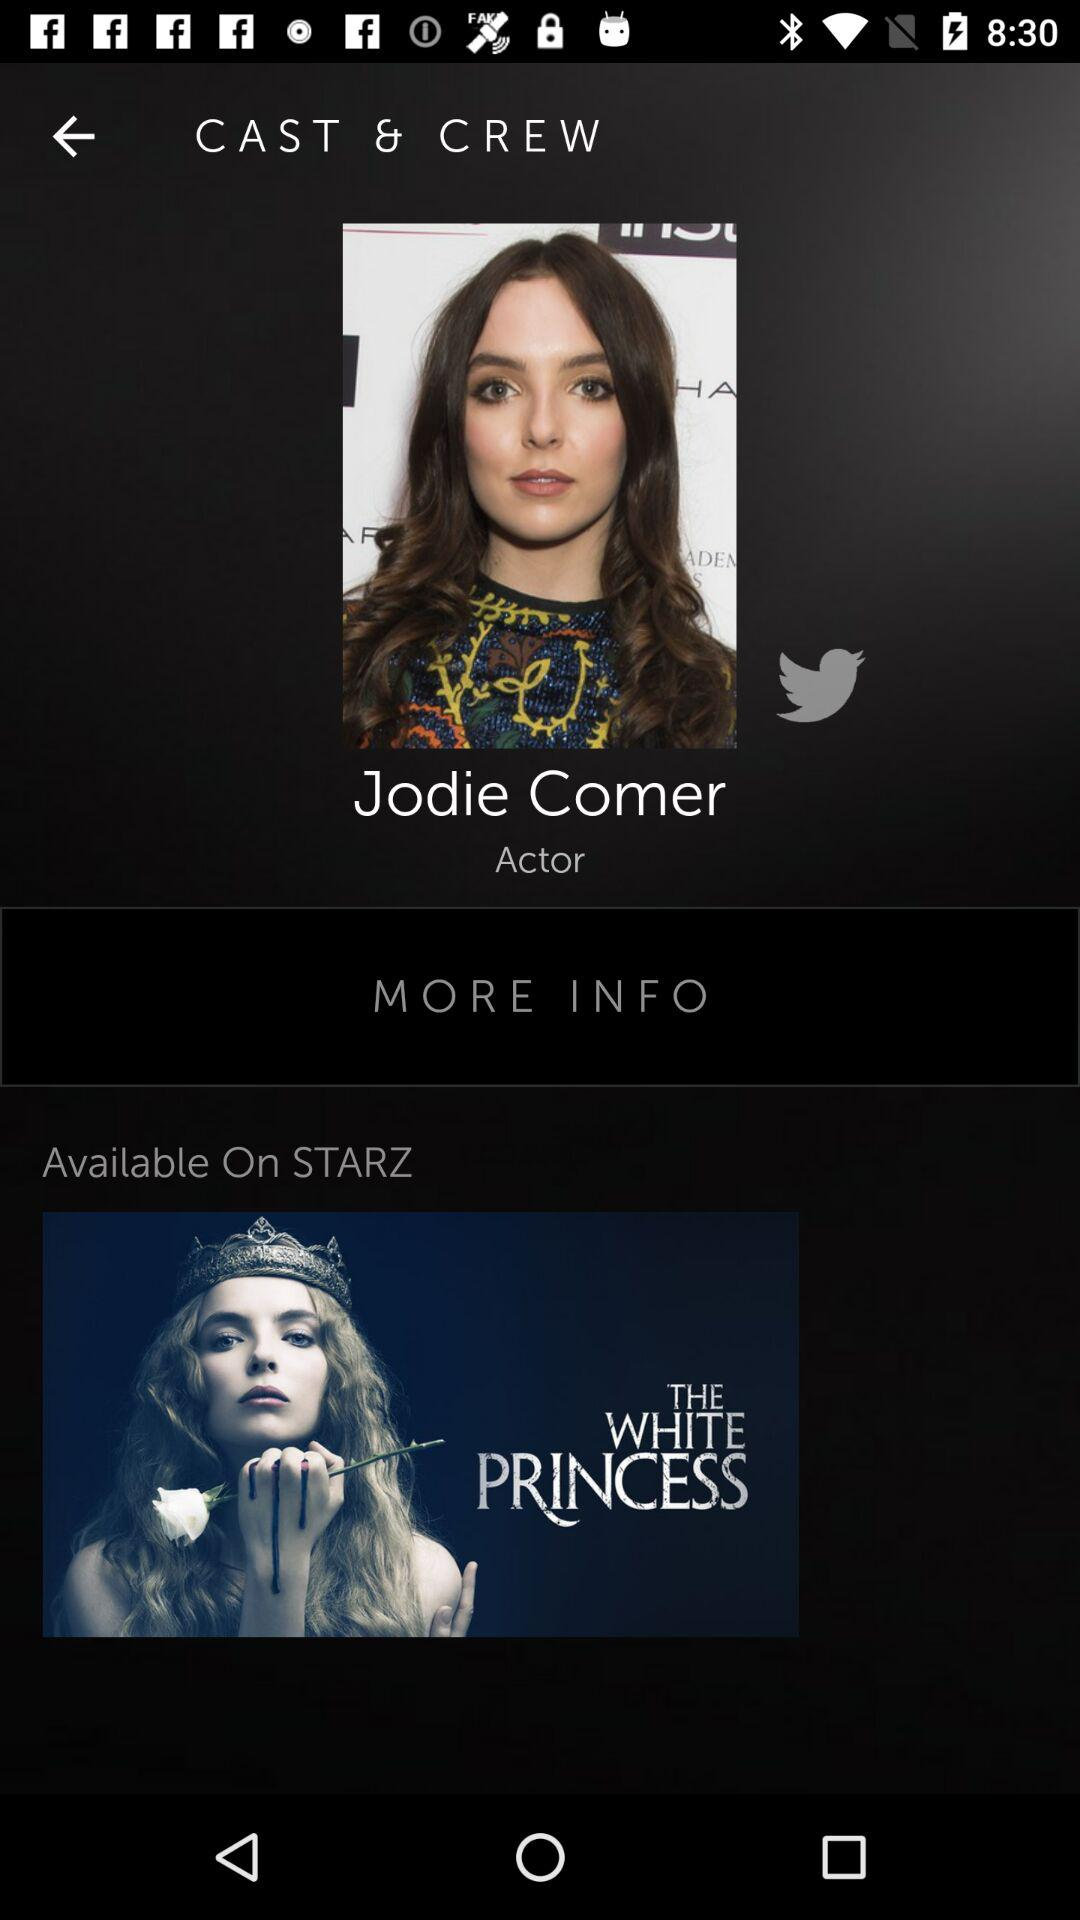What is the name of the actor? The name of the actor is Jodie Comer. 